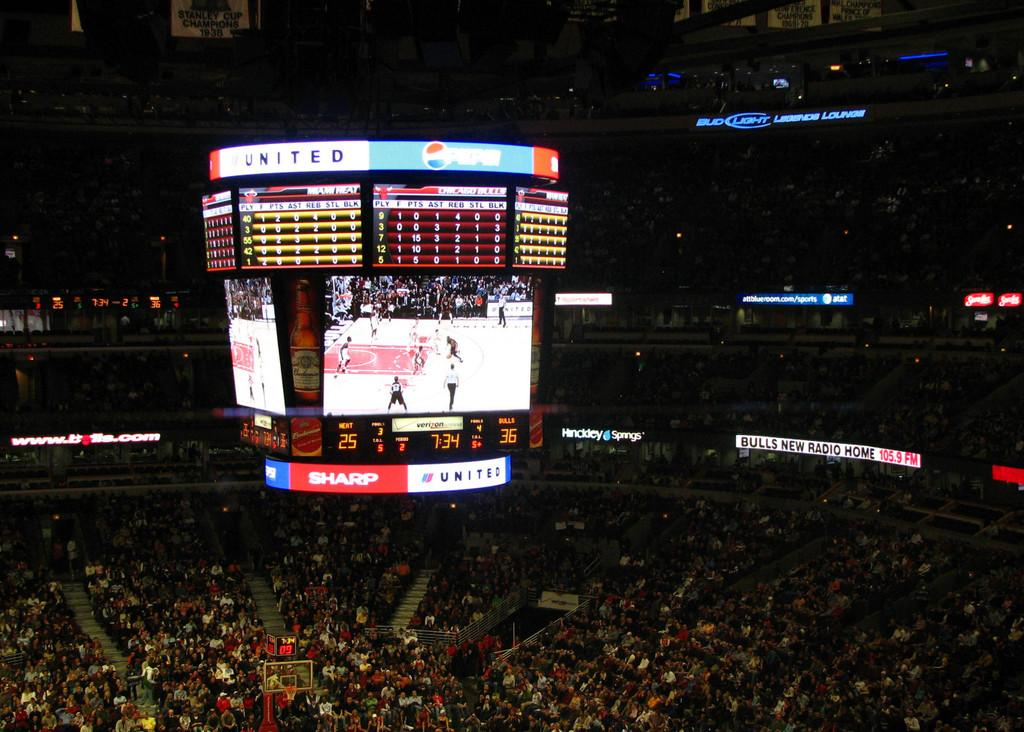<image>
Relay a brief, clear account of the picture shown. A jumbo television in a stadium sponsored by Pepsi and United. 